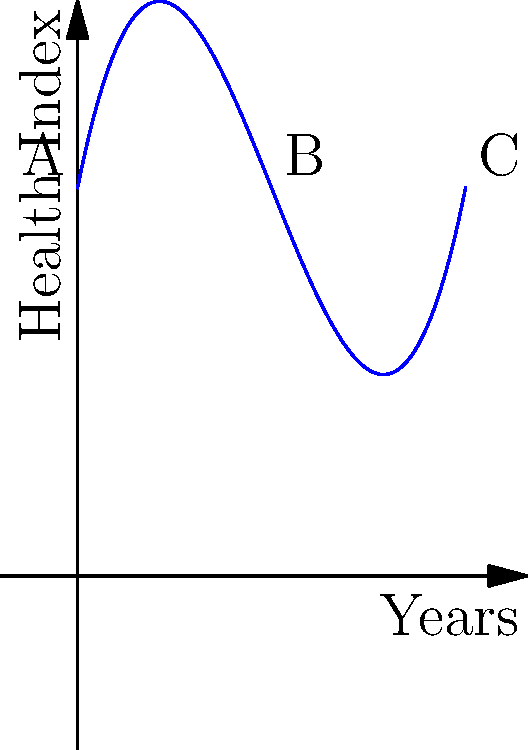As a community health worker, you're analyzing health trends over a 10-year period. The graph shows a polynomial function representing the community's health index over time. The function is given by $f(x) = 0.1x^3 - 1.5x^2 + 5x + 10$, where $x$ represents years and $f(x)$ represents the health index. At which point (A, B, or C) does the community's health index reach its lowest value, and what might this suggest about your intervention strategies? To determine the lowest point of the health index, we need to analyze the function:

1. The function $f(x) = 0.1x^3 - 1.5x^2 + 5x + 10$ is a cubic polynomial.

2. To find the minimum point, we need to find where the derivative $f'(x) = 0.3x^2 - 3x + 5$ equals zero.

3. Solving $0.3x^2 - 3x + 5 = 0$:
   $x = \frac{3 \pm \sqrt{9 - 6}}{0.6} = \frac{3 \pm \sqrt{3}}{0.6}$
   
4. This gives us two critical points: $x \approx 1.54$ and $x \approx 5.46$

5. The point closer to the beginning of our time frame (x = 0) is the minimum.

6. Looking at the graph, we can see that point B (at x = 5) is closest to this minimum.

7. This suggests that the community's health index reaches its lowest value around the middle of the 10-year period, at point B.

8. For intervention strategies, this implies:
   - Initial interventions (years 0-5) may have had limited effectiveness
   - New or intensified interventions after year 5 seem to have improved community health
   - Long-term sustained efforts are crucial for continued improvement
Answer: Point B; suggests need for sustained long-term interventions and evaluation of early strategies. 